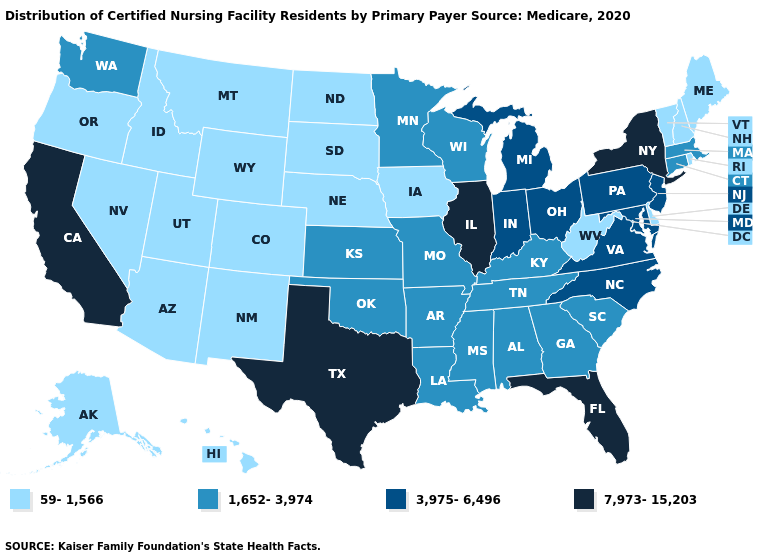Does Florida have the highest value in the USA?
Answer briefly. Yes. What is the lowest value in states that border Utah?
Quick response, please. 59-1,566. Name the states that have a value in the range 7,973-15,203?
Concise answer only. California, Florida, Illinois, New York, Texas. What is the lowest value in the USA?
Be succinct. 59-1,566. Does Pennsylvania have a higher value than Texas?
Write a very short answer. No. What is the value of California?
Give a very brief answer. 7,973-15,203. Does Utah have the lowest value in the West?
Keep it brief. Yes. How many symbols are there in the legend?
Write a very short answer. 4. What is the value of Alaska?
Answer briefly. 59-1,566. Name the states that have a value in the range 1,652-3,974?
Write a very short answer. Alabama, Arkansas, Connecticut, Georgia, Kansas, Kentucky, Louisiana, Massachusetts, Minnesota, Mississippi, Missouri, Oklahoma, South Carolina, Tennessee, Washington, Wisconsin. Name the states that have a value in the range 1,652-3,974?
Concise answer only. Alabama, Arkansas, Connecticut, Georgia, Kansas, Kentucky, Louisiana, Massachusetts, Minnesota, Mississippi, Missouri, Oklahoma, South Carolina, Tennessee, Washington, Wisconsin. Does Nebraska have a higher value than Indiana?
Write a very short answer. No. Name the states that have a value in the range 1,652-3,974?
Concise answer only. Alabama, Arkansas, Connecticut, Georgia, Kansas, Kentucky, Louisiana, Massachusetts, Minnesota, Mississippi, Missouri, Oklahoma, South Carolina, Tennessee, Washington, Wisconsin. How many symbols are there in the legend?
Write a very short answer. 4. Among the states that border Idaho , which have the lowest value?
Give a very brief answer. Montana, Nevada, Oregon, Utah, Wyoming. 